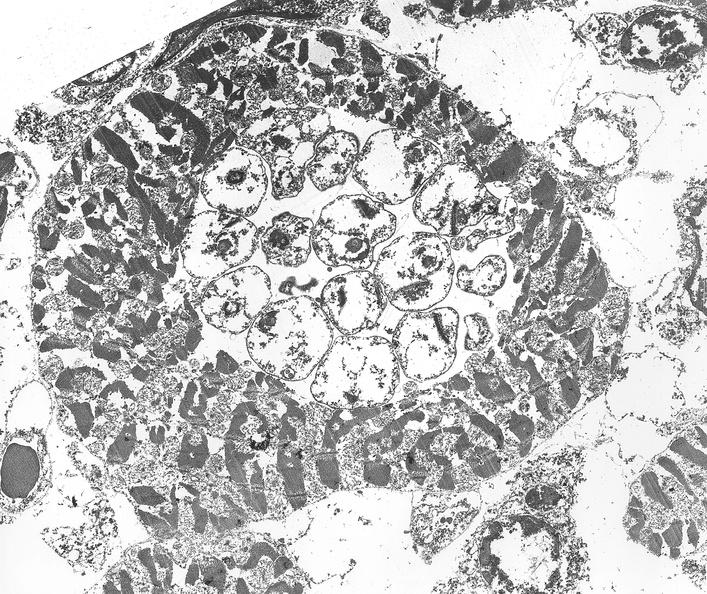does very good example show chagas disease, acute, trypanasoma cruzi?
Answer the question using a single word or phrase. No 